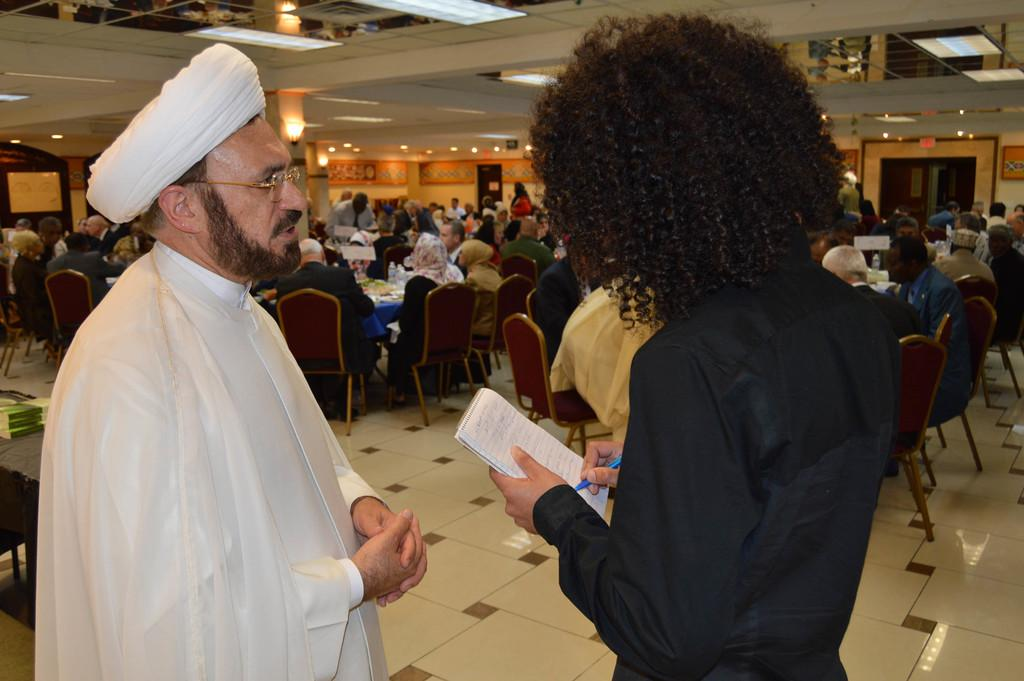How many people are in the image? There is a group of people in the image, but the exact number cannot be determined from the provided facts. What are the people in the image doing? Some people are standing on the floor, and some people are sitting on chairs. What can be seen in the background of the image? There are lights, a wall, and doors visible in the background. What type of steel is used to construct the library in the image? There is no library present in the image, and therefore no steel construction can be observed. Can you tell me how many rings are visible on the fingers of the people in the image? There is no information about rings or fingers in the provided facts, so it cannot be determined from the image. 